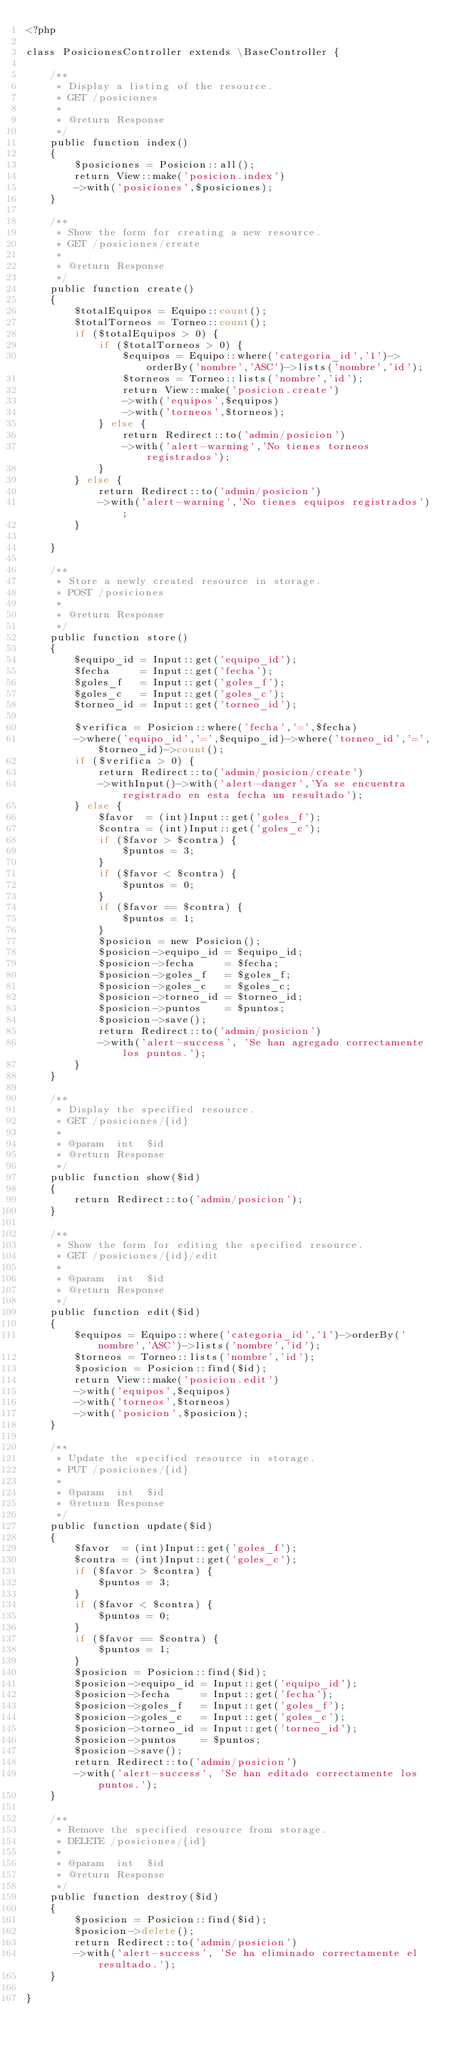<code> <loc_0><loc_0><loc_500><loc_500><_PHP_><?php

class PosicionesController extends \BaseController {

    /**
     * Display a listing of the resource.
     * GET /posiciones
     *
     * @return Response
     */
    public function index()
    {
        $posiciones = Posicion::all();
        return View::make('posicion.index')
        ->with('posiciones',$posiciones);
    }

    /**
     * Show the form for creating a new resource.
     * GET /posiciones/create
     *
     * @return Response
     */
    public function create()
    {
        $totalEquipos = Equipo::count();
        $totalTorneos = Torneo::count();
        if ($totalEquipos > 0) {
            if ($totalTorneos > 0) {
                $equipos = Equipo::where('categoria_id','1')->orderBy('nombre','ASC')->lists('nombre','id');
                $torneos = Torneo::lists('nombre','id');
                return View::make('posicion.create')
                ->with('equipos',$equipos)
                ->with('torneos',$torneos);
            } else {
                return Redirect::to('admin/posicion')
                ->with('alert-warning','No tienes torneos registrados');
            }   
        } else {
            return Redirect::to('admin/posicion')
            ->with('alert-warning','No tienes equipos registrados');
        }
        
    }

    /**
     * Store a newly created resource in storage.
     * POST /posiciones
     *
     * @return Response
     */
    public function store()
    {
        $equipo_id = Input::get('equipo_id');
        $fecha     = Input::get('fecha');
        $goles_f   = Input::get('goles_f');
        $goles_c   = Input::get('goles_c');
        $torneo_id = Input::get('torneo_id');

        $verifica = Posicion::where('fecha','=',$fecha)
        ->where('equipo_id','=',$equipo_id)->where('torneo_id','=',$torneo_id)->count();
        if ($verifica > 0) {
            return Redirect::to('admin/posicion/create')
            ->withInput()->with('alert-danger','Ya se encuentra registrado en esta fecha un resultado');
        } else {
            $favor  = (int)Input::get('goles_f');
            $contra = (int)Input::get('goles_c');
            if ($favor > $contra) {
                $puntos = 3;
            }
            if ($favor < $contra) {
                $puntos = 0;
            }
            if ($favor == $contra) {
                $puntos = 1;
            }
            $posicion = new Posicion();
            $posicion->equipo_id = $equipo_id;
            $posicion->fecha     = $fecha;
            $posicion->goles_f   = $goles_f;
            $posicion->goles_c   = $goles_c;
            $posicion->torneo_id = $torneo_id;
            $posicion->puntos    = $puntos;
            $posicion->save();
            return Redirect::to('admin/posicion')
            ->with('alert-success', 'Se han agregado correctamente los puntos.');
        }
    }

    /**
     * Display the specified resource.
     * GET /posiciones/{id}
     *
     * @param  int  $id
     * @return Response
     */
    public function show($id)
    {
        return Redirect::to('admin/posicion');
    }

    /**
     * Show the form for editing the specified resource.
     * GET /posiciones/{id}/edit
     *
     * @param  int  $id
     * @return Response
     */
    public function edit($id)
    {
        $equipos = Equipo::where('categoria_id','1')->orderBy('nombre','ASC')->lists('nombre','id');
        $torneos = Torneo::lists('nombre','id');
        $posicion = Posicion::find($id);
        return View::make('posicion.edit')
        ->with('equipos',$equipos)
        ->with('torneos',$torneos)
        ->with('posicion',$posicion);
    }

    /**
     * Update the specified resource in storage.
     * PUT /posiciones/{id}
     *
     * @param  int  $id
     * @return Response
     */
    public function update($id)
    {
        $favor  = (int)Input::get('goles_f');
        $contra = (int)Input::get('goles_c');
        if ($favor > $contra) {
            $puntos = 3;
        }
        if ($favor < $contra) {
            $puntos = 0;
        }
        if ($favor == $contra) {
            $puntos = 1;
        }
        $posicion = Posicion::find($id);
        $posicion->equipo_id = Input::get('equipo_id');
        $posicion->fecha     = Input::get('fecha');
        $posicion->goles_f   = Input::get('goles_f');
        $posicion->goles_c   = Input::get('goles_c');
        $posicion->torneo_id = Input::get('torneo_id');
        $posicion->puntos    = $puntos;
        $posicion->save();
        return Redirect::to('admin/posicion')
        ->with('alert-success', 'Se han editado correctamente los puntos.');
    }

    /**
     * Remove the specified resource from storage.
     * DELETE /posiciones/{id}
     *
     * @param  int  $id
     * @return Response
     */
    public function destroy($id)
    {
        $posicion = Posicion::find($id);
        $posicion->delete();
        return Redirect::to('admin/posicion')
        ->with('alert-success', 'Se ha eliminado correctamente el resultado.');
    }

}</code> 